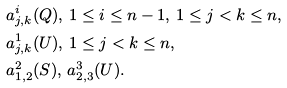<formula> <loc_0><loc_0><loc_500><loc_500>& a _ { j , k } ^ { i } ( Q ) , \, 1 \leq i \leq n - 1 , \, 1 \leq j < k \leq n , \\ & a _ { j , k } ^ { 1 } ( U ) , \, 1 \leq j < k \leq n , \\ & a _ { 1 , 2 } ^ { 2 } ( S ) , \, a _ { 2 , 3 } ^ { 3 } ( U ) .</formula> 